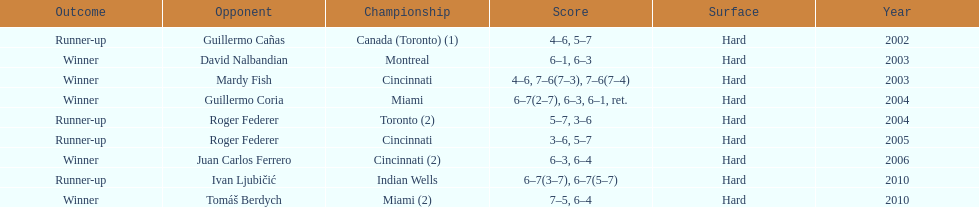How many times has he been runner-up? 4. 